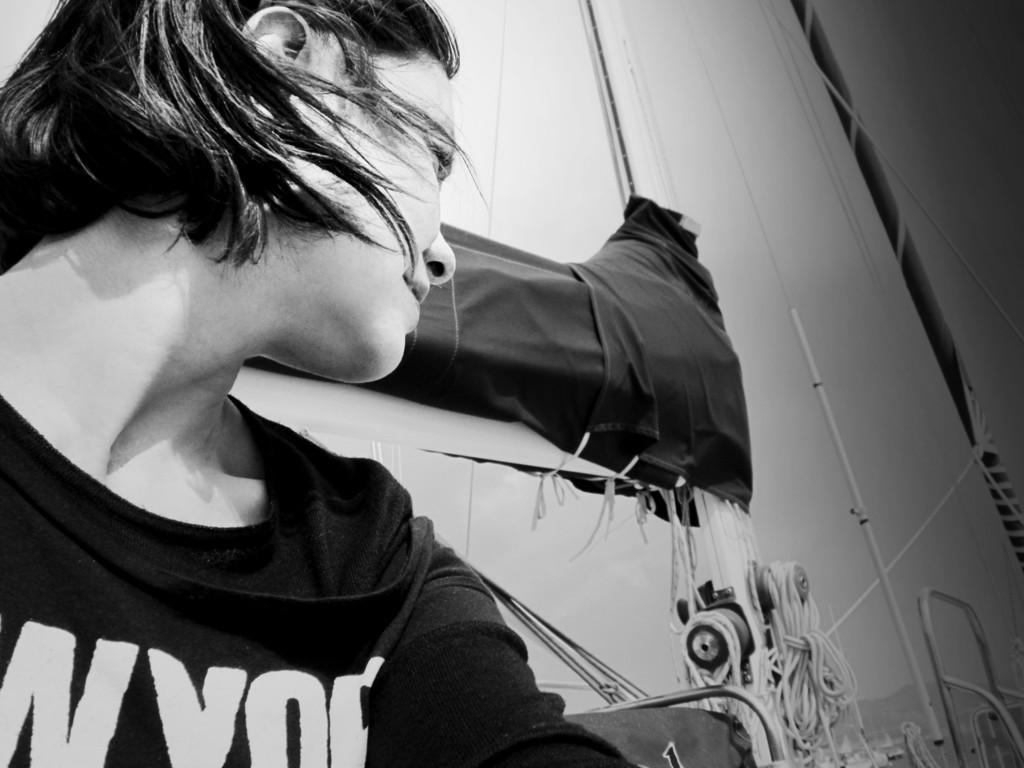Who is present in the image? There is a woman in the image. What is the woman doing in the image? The woman is on a boat. What objects can be seen in the image related to the boat? There are poles and ropes in the image. What type of material is visible in the image? There is cloth in the image. What is visible in the background of the image? The sky is visible in the image. How is the image presented in terms of color? The image is in black and white mode. What type of mark can be seen on the woman's face in the image? There is no mark visible on the woman's face in the image. What type of work is the woman doing in the image? The image does not provide information about the woman's work, as it only shows her on a boat. How many fish can be seen in the image? There are no fish present in the image. 